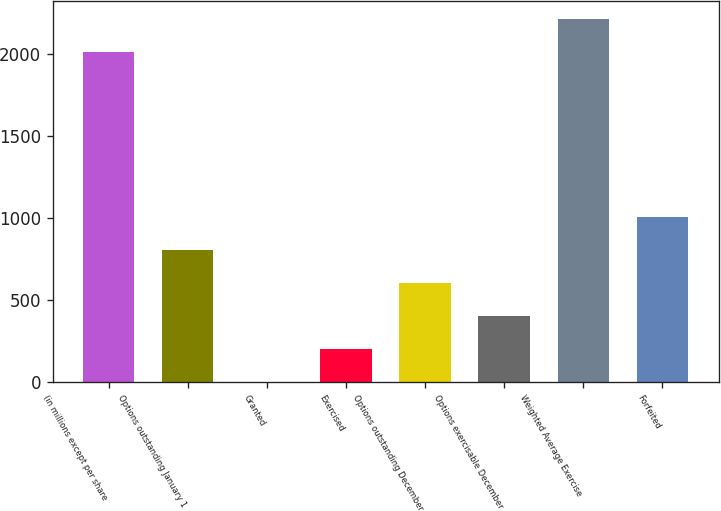<chart> <loc_0><loc_0><loc_500><loc_500><bar_chart><fcel>(in millions except per share<fcel>Options outstanding January 1<fcel>Granted<fcel>Exercised<fcel>Options outstanding December<fcel>Options exercisable December<fcel>Weighted Average Exercise<fcel>Forfeited<nl><fcel>2012<fcel>805.52<fcel>1.2<fcel>202.28<fcel>604.44<fcel>403.36<fcel>2213.08<fcel>1006.6<nl></chart> 